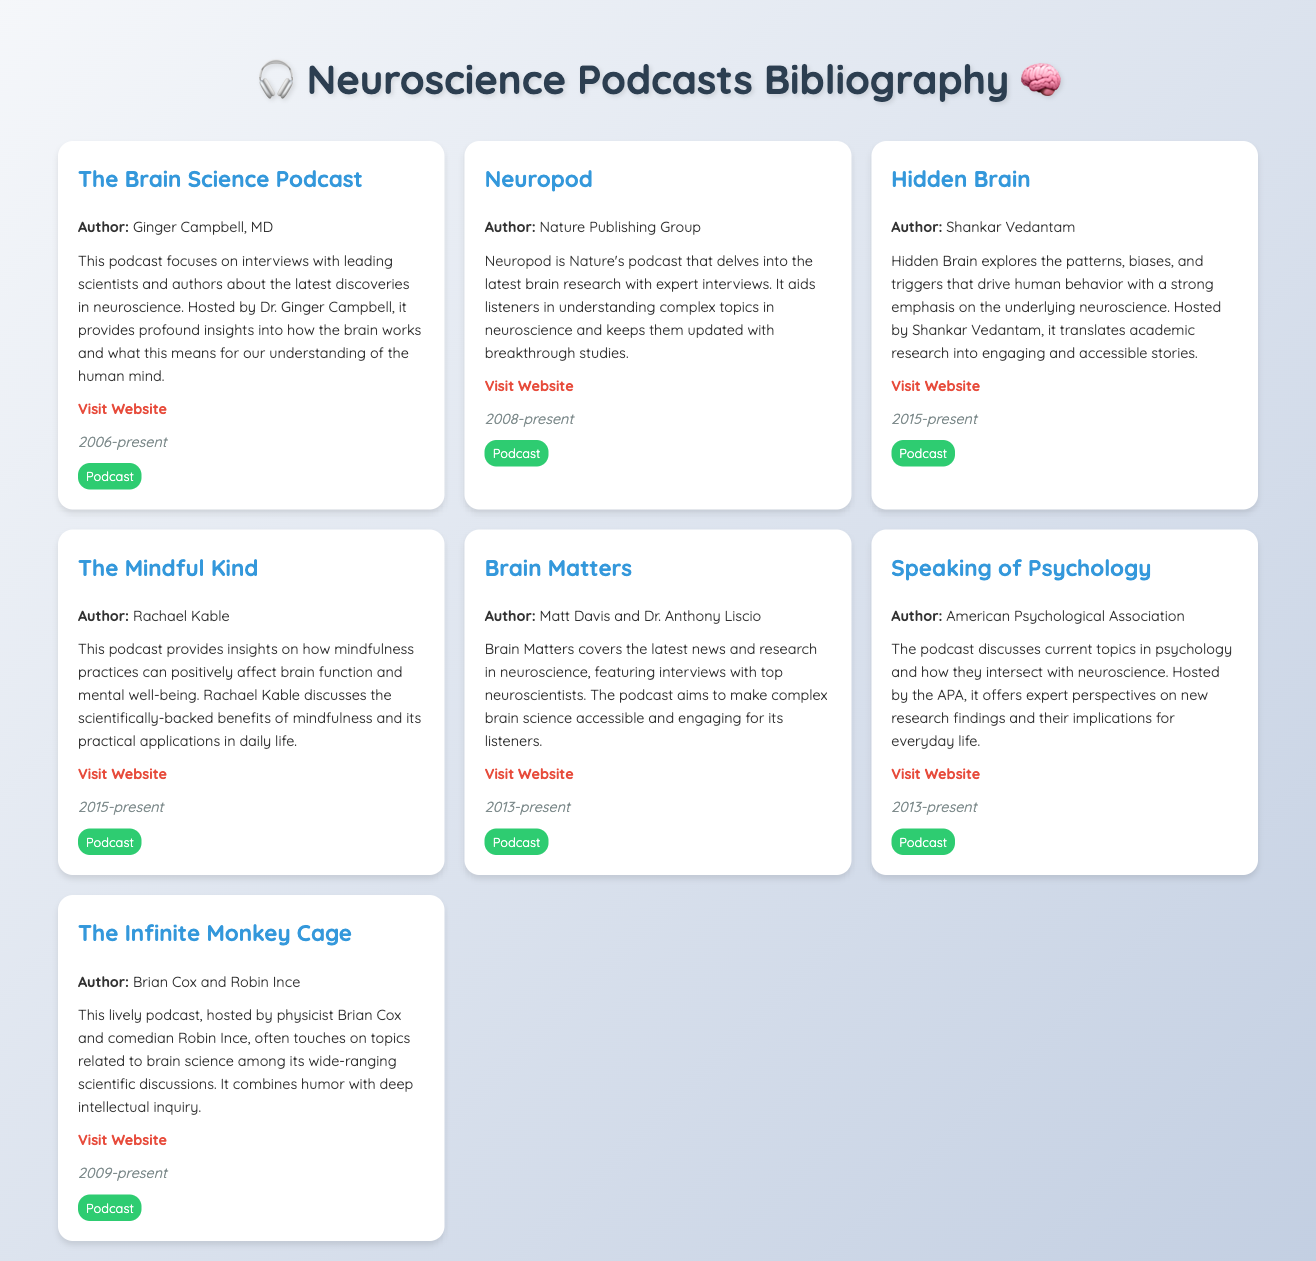What is the title of the first podcast listed? The title of the first podcast is found in the entry of the document, which displays "The Brain Science Podcast."
Answer: The Brain Science Podcast Who is the host of "Hidden Brain"? The document states that "Hidden Brain" is hosted by Shankar Vedantam.
Answer: Shankar Vedantam In what year did "Neuropod" begin? The start date for "Neuropod" can be found in the date section, listed as "2008-present."
Answer: 2008 Which podcast is associated with the American Psychological Association? The entry for the American Psychological Association indicates the title related to their work is "Speaking of Psychology."
Answer: Speaking of Psychology How many podcasts are listed in the bibliography? The document contains a total of seven entries, each representing a different podcast.
Answer: 7 What genre does "The Infinite Monkey Cage" combine? The document notes that "The Infinite Monkey Cage" combines humor with deep intellectual inquiry.
Answer: Humor and deep intellectual inquiry Who are the authors of "Brain Matters"? The document presents the authors of "Brain Matters" as Matt Davis and Dr. Anthony Liscio.
Answer: Matt Davis and Dr. Anthony Liscio What is the main theme of "The Mindful Kind"? The entry reveals that the main theme of "The Mindful Kind" is mindfulness practices and their benefits for brain function.
Answer: Mindfulness practices and their benefits for brain function 